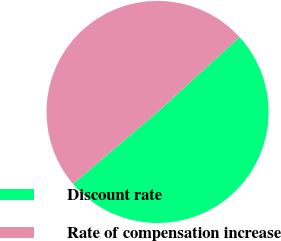<chart> <loc_0><loc_0><loc_500><loc_500><pie_chart><fcel>Discount rate<fcel>Rate of compensation increase<nl><fcel>50.54%<fcel>49.46%<nl></chart> 